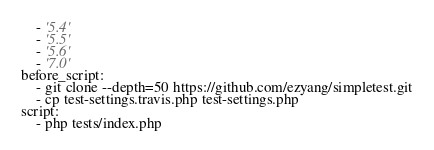Convert code to text. <code><loc_0><loc_0><loc_500><loc_500><_YAML_>    - '5.4'
    - '5.5'
    - '5.6'
    - '7.0'
before_script:
    - git clone --depth=50 https://github.com/ezyang/simpletest.git
    - cp test-settings.travis.php test-settings.php
script:
    - php tests/index.php
</code> 